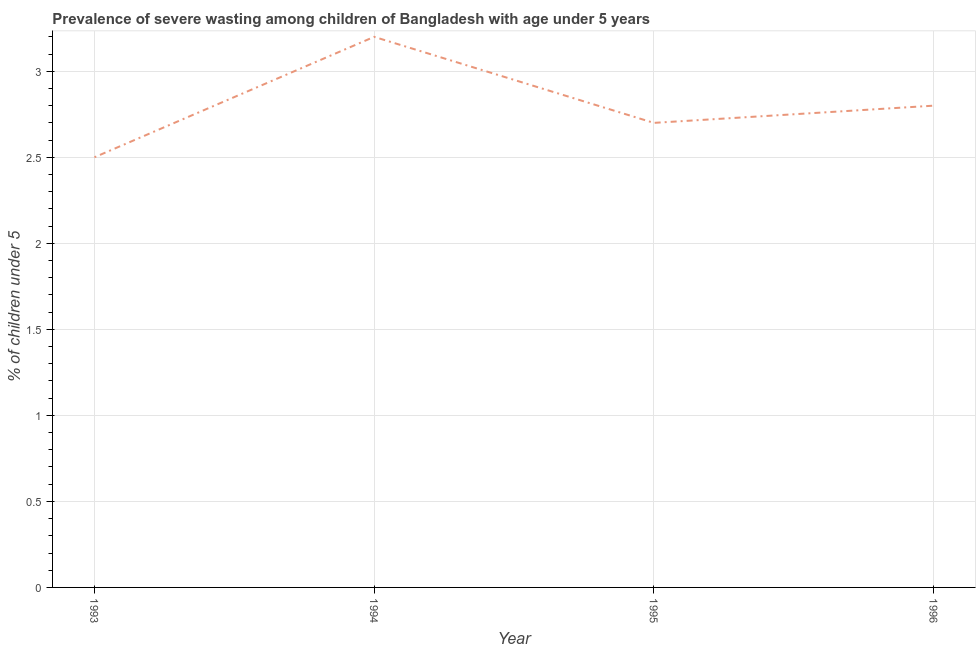What is the prevalence of severe wasting in 1994?
Your response must be concise. 3.2. Across all years, what is the maximum prevalence of severe wasting?
Offer a terse response. 3.2. In which year was the prevalence of severe wasting maximum?
Your response must be concise. 1994. What is the sum of the prevalence of severe wasting?
Your answer should be compact. 11.2. What is the difference between the prevalence of severe wasting in 1993 and 1995?
Offer a terse response. -0.2. What is the average prevalence of severe wasting per year?
Make the answer very short. 2.8. What is the median prevalence of severe wasting?
Your response must be concise. 2.75. Do a majority of the years between 1994 and 1993 (inclusive) have prevalence of severe wasting greater than 1.5 %?
Offer a terse response. No. What is the ratio of the prevalence of severe wasting in 1993 to that in 1995?
Ensure brevity in your answer.  0.93. Is the prevalence of severe wasting in 1993 less than that in 1995?
Your response must be concise. Yes. Is the difference between the prevalence of severe wasting in 1993 and 1996 greater than the difference between any two years?
Make the answer very short. No. What is the difference between the highest and the second highest prevalence of severe wasting?
Give a very brief answer. 0.4. Is the sum of the prevalence of severe wasting in 1993 and 1994 greater than the maximum prevalence of severe wasting across all years?
Offer a terse response. Yes. What is the difference between the highest and the lowest prevalence of severe wasting?
Offer a terse response. 0.7. Does the prevalence of severe wasting monotonically increase over the years?
Your response must be concise. No. How many years are there in the graph?
Ensure brevity in your answer.  4. Are the values on the major ticks of Y-axis written in scientific E-notation?
Provide a short and direct response. No. Does the graph contain grids?
Your answer should be compact. Yes. What is the title of the graph?
Offer a terse response. Prevalence of severe wasting among children of Bangladesh with age under 5 years. What is the label or title of the Y-axis?
Offer a very short reply.  % of children under 5. What is the  % of children under 5 of 1993?
Your response must be concise. 2.5. What is the  % of children under 5 in 1994?
Your response must be concise. 3.2. What is the  % of children under 5 in 1995?
Your response must be concise. 2.7. What is the  % of children under 5 of 1996?
Offer a terse response. 2.8. What is the difference between the  % of children under 5 in 1993 and 1994?
Your response must be concise. -0.7. What is the difference between the  % of children under 5 in 1993 and 1996?
Offer a terse response. -0.3. What is the difference between the  % of children under 5 in 1994 and 1996?
Make the answer very short. 0.4. What is the difference between the  % of children under 5 in 1995 and 1996?
Keep it short and to the point. -0.1. What is the ratio of the  % of children under 5 in 1993 to that in 1994?
Your answer should be very brief. 0.78. What is the ratio of the  % of children under 5 in 1993 to that in 1995?
Your answer should be compact. 0.93. What is the ratio of the  % of children under 5 in 1993 to that in 1996?
Your answer should be very brief. 0.89. What is the ratio of the  % of children under 5 in 1994 to that in 1995?
Offer a very short reply. 1.19. What is the ratio of the  % of children under 5 in 1994 to that in 1996?
Give a very brief answer. 1.14. 